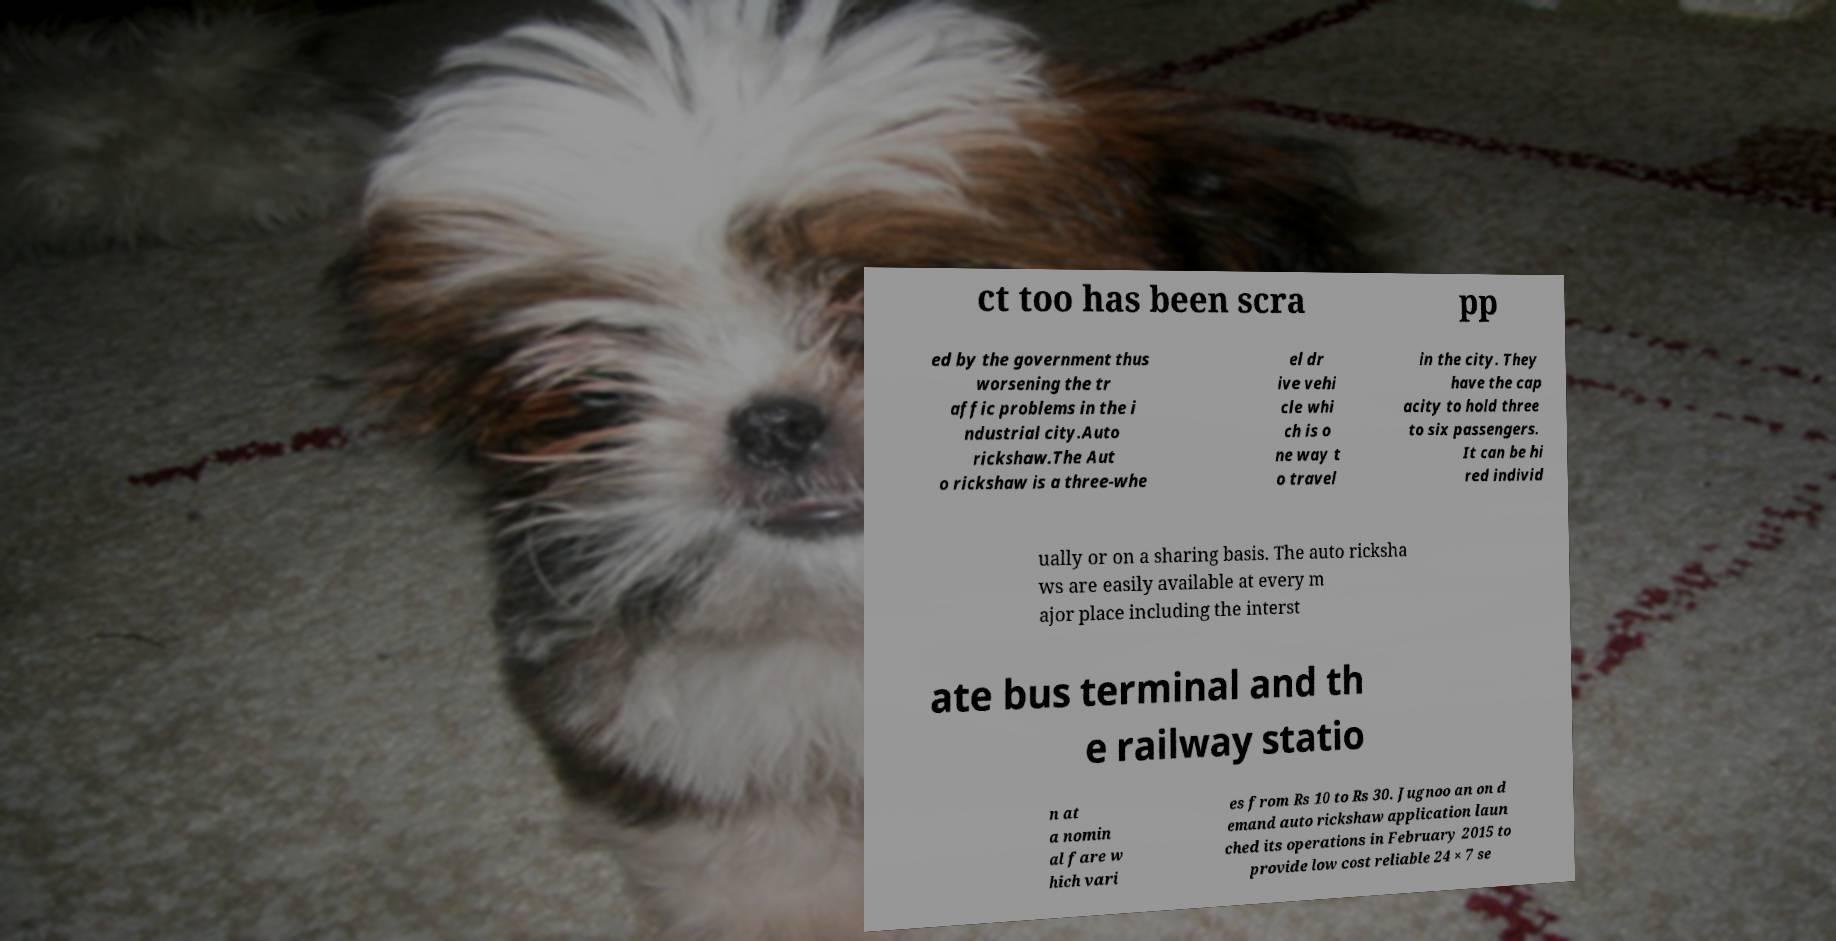Can you read and provide the text displayed in the image?This photo seems to have some interesting text. Can you extract and type it out for me? ct too has been scra pp ed by the government thus worsening the tr affic problems in the i ndustrial city.Auto rickshaw.The Aut o rickshaw is a three-whe el dr ive vehi cle whi ch is o ne way t o travel in the city. They have the cap acity to hold three to six passengers. It can be hi red individ ually or on a sharing basis. The auto ricksha ws are easily available at every m ajor place including the interst ate bus terminal and th e railway statio n at a nomin al fare w hich vari es from ₨ 10 to ₨ 30. Jugnoo an on d emand auto rickshaw application laun ched its operations in February 2015 to provide low cost reliable 24 × 7 se 